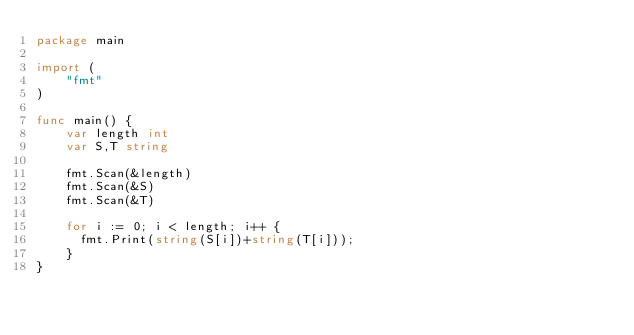Convert code to text. <code><loc_0><loc_0><loc_500><loc_500><_Go_>package main

import (
    "fmt"
)

func main() {
    var length int
    var S,T string
  
    fmt.Scan(&length)
    fmt.Scan(&S)
    fmt.Scan(&T)
  
    for i := 0; i < length; i++ {
      fmt.Print(string(S[i])+string(T[i]));
    }
}</code> 